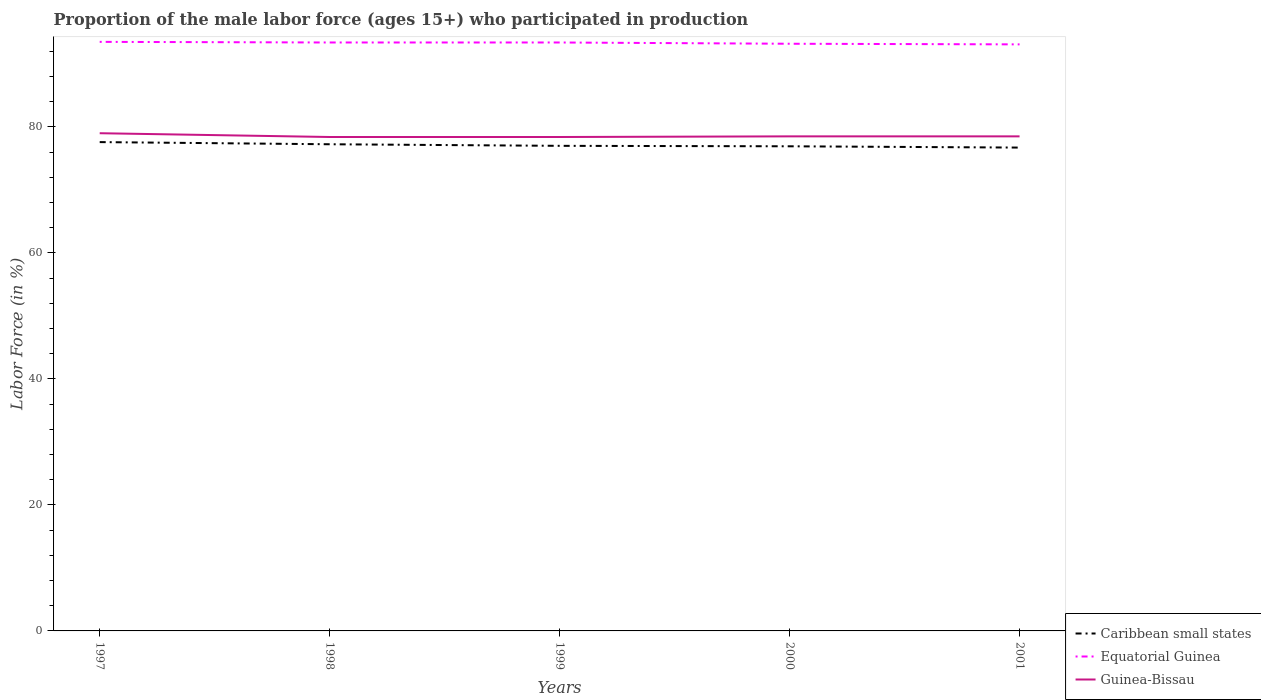Is the number of lines equal to the number of legend labels?
Give a very brief answer. Yes. Across all years, what is the maximum proportion of the male labor force who participated in production in Caribbean small states?
Your answer should be very brief. 76.72. In which year was the proportion of the male labor force who participated in production in Caribbean small states maximum?
Provide a short and direct response. 2001. What is the total proportion of the male labor force who participated in production in Caribbean small states in the graph?
Your answer should be compact. 0.07. What is the difference between the highest and the second highest proportion of the male labor force who participated in production in Caribbean small states?
Your response must be concise. 0.87. What is the difference between two consecutive major ticks on the Y-axis?
Your response must be concise. 20. Are the values on the major ticks of Y-axis written in scientific E-notation?
Offer a very short reply. No. Where does the legend appear in the graph?
Offer a terse response. Bottom right. How are the legend labels stacked?
Your answer should be compact. Vertical. What is the title of the graph?
Offer a very short reply. Proportion of the male labor force (ages 15+) who participated in production. Does "Euro area" appear as one of the legend labels in the graph?
Your answer should be compact. No. What is the label or title of the X-axis?
Provide a short and direct response. Years. What is the Labor Force (in %) in Caribbean small states in 1997?
Make the answer very short. 77.59. What is the Labor Force (in %) in Equatorial Guinea in 1997?
Offer a terse response. 93.5. What is the Labor Force (in %) in Guinea-Bissau in 1997?
Give a very brief answer. 79. What is the Labor Force (in %) in Caribbean small states in 1998?
Your answer should be compact. 77.25. What is the Labor Force (in %) in Equatorial Guinea in 1998?
Give a very brief answer. 93.4. What is the Labor Force (in %) of Guinea-Bissau in 1998?
Give a very brief answer. 78.4. What is the Labor Force (in %) of Caribbean small states in 1999?
Offer a terse response. 77. What is the Labor Force (in %) of Equatorial Guinea in 1999?
Ensure brevity in your answer.  93.4. What is the Labor Force (in %) in Guinea-Bissau in 1999?
Make the answer very short. 78.4. What is the Labor Force (in %) in Caribbean small states in 2000?
Ensure brevity in your answer.  76.92. What is the Labor Force (in %) in Equatorial Guinea in 2000?
Ensure brevity in your answer.  93.2. What is the Labor Force (in %) of Guinea-Bissau in 2000?
Provide a short and direct response. 78.5. What is the Labor Force (in %) in Caribbean small states in 2001?
Make the answer very short. 76.72. What is the Labor Force (in %) of Equatorial Guinea in 2001?
Offer a very short reply. 93.1. What is the Labor Force (in %) in Guinea-Bissau in 2001?
Ensure brevity in your answer.  78.5. Across all years, what is the maximum Labor Force (in %) of Caribbean small states?
Your answer should be compact. 77.59. Across all years, what is the maximum Labor Force (in %) in Equatorial Guinea?
Give a very brief answer. 93.5. Across all years, what is the maximum Labor Force (in %) of Guinea-Bissau?
Your answer should be compact. 79. Across all years, what is the minimum Labor Force (in %) of Caribbean small states?
Your answer should be compact. 76.72. Across all years, what is the minimum Labor Force (in %) of Equatorial Guinea?
Provide a succinct answer. 93.1. Across all years, what is the minimum Labor Force (in %) in Guinea-Bissau?
Offer a very short reply. 78.4. What is the total Labor Force (in %) in Caribbean small states in the graph?
Keep it short and to the point. 385.48. What is the total Labor Force (in %) in Equatorial Guinea in the graph?
Offer a terse response. 466.6. What is the total Labor Force (in %) in Guinea-Bissau in the graph?
Your answer should be very brief. 392.8. What is the difference between the Labor Force (in %) of Caribbean small states in 1997 and that in 1998?
Ensure brevity in your answer.  0.34. What is the difference between the Labor Force (in %) of Equatorial Guinea in 1997 and that in 1998?
Ensure brevity in your answer.  0.1. What is the difference between the Labor Force (in %) of Caribbean small states in 1997 and that in 1999?
Make the answer very short. 0.59. What is the difference between the Labor Force (in %) of Equatorial Guinea in 1997 and that in 1999?
Provide a short and direct response. 0.1. What is the difference between the Labor Force (in %) of Guinea-Bissau in 1997 and that in 1999?
Ensure brevity in your answer.  0.6. What is the difference between the Labor Force (in %) in Caribbean small states in 1997 and that in 2000?
Ensure brevity in your answer.  0.67. What is the difference between the Labor Force (in %) in Equatorial Guinea in 1997 and that in 2000?
Your response must be concise. 0.3. What is the difference between the Labor Force (in %) of Guinea-Bissau in 1997 and that in 2000?
Give a very brief answer. 0.5. What is the difference between the Labor Force (in %) of Caribbean small states in 1997 and that in 2001?
Your response must be concise. 0.87. What is the difference between the Labor Force (in %) of Equatorial Guinea in 1997 and that in 2001?
Keep it short and to the point. 0.4. What is the difference between the Labor Force (in %) of Caribbean small states in 1998 and that in 1999?
Keep it short and to the point. 0.25. What is the difference between the Labor Force (in %) of Equatorial Guinea in 1998 and that in 1999?
Give a very brief answer. 0. What is the difference between the Labor Force (in %) of Guinea-Bissau in 1998 and that in 1999?
Make the answer very short. 0. What is the difference between the Labor Force (in %) in Caribbean small states in 1998 and that in 2000?
Your answer should be compact. 0.32. What is the difference between the Labor Force (in %) in Equatorial Guinea in 1998 and that in 2000?
Provide a succinct answer. 0.2. What is the difference between the Labor Force (in %) of Caribbean small states in 1998 and that in 2001?
Provide a succinct answer. 0.53. What is the difference between the Labor Force (in %) in Equatorial Guinea in 1998 and that in 2001?
Offer a terse response. 0.3. What is the difference between the Labor Force (in %) of Caribbean small states in 1999 and that in 2000?
Offer a terse response. 0.07. What is the difference between the Labor Force (in %) of Equatorial Guinea in 1999 and that in 2000?
Ensure brevity in your answer.  0.2. What is the difference between the Labor Force (in %) in Guinea-Bissau in 1999 and that in 2000?
Keep it short and to the point. -0.1. What is the difference between the Labor Force (in %) of Caribbean small states in 1999 and that in 2001?
Your answer should be very brief. 0.28. What is the difference between the Labor Force (in %) in Equatorial Guinea in 1999 and that in 2001?
Keep it short and to the point. 0.3. What is the difference between the Labor Force (in %) in Caribbean small states in 2000 and that in 2001?
Give a very brief answer. 0.2. What is the difference between the Labor Force (in %) in Guinea-Bissau in 2000 and that in 2001?
Provide a succinct answer. 0. What is the difference between the Labor Force (in %) in Caribbean small states in 1997 and the Labor Force (in %) in Equatorial Guinea in 1998?
Provide a short and direct response. -15.81. What is the difference between the Labor Force (in %) in Caribbean small states in 1997 and the Labor Force (in %) in Guinea-Bissau in 1998?
Your response must be concise. -0.81. What is the difference between the Labor Force (in %) of Caribbean small states in 1997 and the Labor Force (in %) of Equatorial Guinea in 1999?
Keep it short and to the point. -15.81. What is the difference between the Labor Force (in %) in Caribbean small states in 1997 and the Labor Force (in %) in Guinea-Bissau in 1999?
Provide a succinct answer. -0.81. What is the difference between the Labor Force (in %) of Caribbean small states in 1997 and the Labor Force (in %) of Equatorial Guinea in 2000?
Offer a terse response. -15.61. What is the difference between the Labor Force (in %) of Caribbean small states in 1997 and the Labor Force (in %) of Guinea-Bissau in 2000?
Give a very brief answer. -0.91. What is the difference between the Labor Force (in %) in Caribbean small states in 1997 and the Labor Force (in %) in Equatorial Guinea in 2001?
Your answer should be very brief. -15.51. What is the difference between the Labor Force (in %) of Caribbean small states in 1997 and the Labor Force (in %) of Guinea-Bissau in 2001?
Make the answer very short. -0.91. What is the difference between the Labor Force (in %) of Equatorial Guinea in 1997 and the Labor Force (in %) of Guinea-Bissau in 2001?
Give a very brief answer. 15. What is the difference between the Labor Force (in %) in Caribbean small states in 1998 and the Labor Force (in %) in Equatorial Guinea in 1999?
Make the answer very short. -16.15. What is the difference between the Labor Force (in %) in Caribbean small states in 1998 and the Labor Force (in %) in Guinea-Bissau in 1999?
Your answer should be very brief. -1.15. What is the difference between the Labor Force (in %) in Caribbean small states in 1998 and the Labor Force (in %) in Equatorial Guinea in 2000?
Make the answer very short. -15.95. What is the difference between the Labor Force (in %) of Caribbean small states in 1998 and the Labor Force (in %) of Guinea-Bissau in 2000?
Provide a short and direct response. -1.25. What is the difference between the Labor Force (in %) in Caribbean small states in 1998 and the Labor Force (in %) in Equatorial Guinea in 2001?
Your response must be concise. -15.85. What is the difference between the Labor Force (in %) of Caribbean small states in 1998 and the Labor Force (in %) of Guinea-Bissau in 2001?
Ensure brevity in your answer.  -1.25. What is the difference between the Labor Force (in %) of Caribbean small states in 1999 and the Labor Force (in %) of Equatorial Guinea in 2000?
Your response must be concise. -16.2. What is the difference between the Labor Force (in %) of Caribbean small states in 1999 and the Labor Force (in %) of Guinea-Bissau in 2000?
Offer a terse response. -1.5. What is the difference between the Labor Force (in %) of Caribbean small states in 1999 and the Labor Force (in %) of Equatorial Guinea in 2001?
Ensure brevity in your answer.  -16.1. What is the difference between the Labor Force (in %) of Caribbean small states in 1999 and the Labor Force (in %) of Guinea-Bissau in 2001?
Keep it short and to the point. -1.5. What is the difference between the Labor Force (in %) of Caribbean small states in 2000 and the Labor Force (in %) of Equatorial Guinea in 2001?
Make the answer very short. -16.18. What is the difference between the Labor Force (in %) in Caribbean small states in 2000 and the Labor Force (in %) in Guinea-Bissau in 2001?
Give a very brief answer. -1.58. What is the difference between the Labor Force (in %) in Equatorial Guinea in 2000 and the Labor Force (in %) in Guinea-Bissau in 2001?
Your response must be concise. 14.7. What is the average Labor Force (in %) of Caribbean small states per year?
Your answer should be compact. 77.1. What is the average Labor Force (in %) in Equatorial Guinea per year?
Make the answer very short. 93.32. What is the average Labor Force (in %) of Guinea-Bissau per year?
Offer a terse response. 78.56. In the year 1997, what is the difference between the Labor Force (in %) in Caribbean small states and Labor Force (in %) in Equatorial Guinea?
Make the answer very short. -15.91. In the year 1997, what is the difference between the Labor Force (in %) in Caribbean small states and Labor Force (in %) in Guinea-Bissau?
Keep it short and to the point. -1.41. In the year 1998, what is the difference between the Labor Force (in %) of Caribbean small states and Labor Force (in %) of Equatorial Guinea?
Your response must be concise. -16.15. In the year 1998, what is the difference between the Labor Force (in %) of Caribbean small states and Labor Force (in %) of Guinea-Bissau?
Your response must be concise. -1.15. In the year 1998, what is the difference between the Labor Force (in %) of Equatorial Guinea and Labor Force (in %) of Guinea-Bissau?
Provide a succinct answer. 15. In the year 1999, what is the difference between the Labor Force (in %) in Caribbean small states and Labor Force (in %) in Equatorial Guinea?
Give a very brief answer. -16.4. In the year 1999, what is the difference between the Labor Force (in %) in Caribbean small states and Labor Force (in %) in Guinea-Bissau?
Your answer should be compact. -1.4. In the year 1999, what is the difference between the Labor Force (in %) of Equatorial Guinea and Labor Force (in %) of Guinea-Bissau?
Your response must be concise. 15. In the year 2000, what is the difference between the Labor Force (in %) of Caribbean small states and Labor Force (in %) of Equatorial Guinea?
Ensure brevity in your answer.  -16.28. In the year 2000, what is the difference between the Labor Force (in %) in Caribbean small states and Labor Force (in %) in Guinea-Bissau?
Give a very brief answer. -1.58. In the year 2001, what is the difference between the Labor Force (in %) of Caribbean small states and Labor Force (in %) of Equatorial Guinea?
Make the answer very short. -16.38. In the year 2001, what is the difference between the Labor Force (in %) of Caribbean small states and Labor Force (in %) of Guinea-Bissau?
Make the answer very short. -1.78. What is the ratio of the Labor Force (in %) of Caribbean small states in 1997 to that in 1998?
Your answer should be compact. 1. What is the ratio of the Labor Force (in %) in Guinea-Bissau in 1997 to that in 1998?
Your answer should be compact. 1.01. What is the ratio of the Labor Force (in %) of Caribbean small states in 1997 to that in 1999?
Provide a succinct answer. 1.01. What is the ratio of the Labor Force (in %) in Equatorial Guinea in 1997 to that in 1999?
Give a very brief answer. 1. What is the ratio of the Labor Force (in %) in Guinea-Bissau in 1997 to that in 1999?
Ensure brevity in your answer.  1.01. What is the ratio of the Labor Force (in %) of Caribbean small states in 1997 to that in 2000?
Offer a very short reply. 1.01. What is the ratio of the Labor Force (in %) in Equatorial Guinea in 1997 to that in 2000?
Ensure brevity in your answer.  1. What is the ratio of the Labor Force (in %) of Guinea-Bissau in 1997 to that in 2000?
Keep it short and to the point. 1.01. What is the ratio of the Labor Force (in %) in Caribbean small states in 1997 to that in 2001?
Keep it short and to the point. 1.01. What is the ratio of the Labor Force (in %) of Equatorial Guinea in 1997 to that in 2001?
Ensure brevity in your answer.  1. What is the ratio of the Labor Force (in %) of Guinea-Bissau in 1997 to that in 2001?
Your response must be concise. 1.01. What is the ratio of the Labor Force (in %) of Guinea-Bissau in 1998 to that in 1999?
Your response must be concise. 1. What is the ratio of the Labor Force (in %) of Caribbean small states in 1998 to that in 2000?
Provide a succinct answer. 1. What is the ratio of the Labor Force (in %) in Caribbean small states in 1998 to that in 2001?
Make the answer very short. 1.01. What is the ratio of the Labor Force (in %) of Equatorial Guinea in 1998 to that in 2001?
Provide a succinct answer. 1. What is the ratio of the Labor Force (in %) of Guinea-Bissau in 1998 to that in 2001?
Provide a succinct answer. 1. What is the ratio of the Labor Force (in %) in Equatorial Guinea in 1999 to that in 2000?
Offer a very short reply. 1. What is the ratio of the Labor Force (in %) in Guinea-Bissau in 1999 to that in 2000?
Keep it short and to the point. 1. What is the ratio of the Labor Force (in %) of Guinea-Bissau in 1999 to that in 2001?
Your response must be concise. 1. What is the ratio of the Labor Force (in %) in Caribbean small states in 2000 to that in 2001?
Offer a terse response. 1. What is the ratio of the Labor Force (in %) in Guinea-Bissau in 2000 to that in 2001?
Provide a succinct answer. 1. What is the difference between the highest and the second highest Labor Force (in %) of Caribbean small states?
Offer a very short reply. 0.34. What is the difference between the highest and the lowest Labor Force (in %) in Caribbean small states?
Offer a terse response. 0.87. What is the difference between the highest and the lowest Labor Force (in %) in Equatorial Guinea?
Provide a short and direct response. 0.4. 